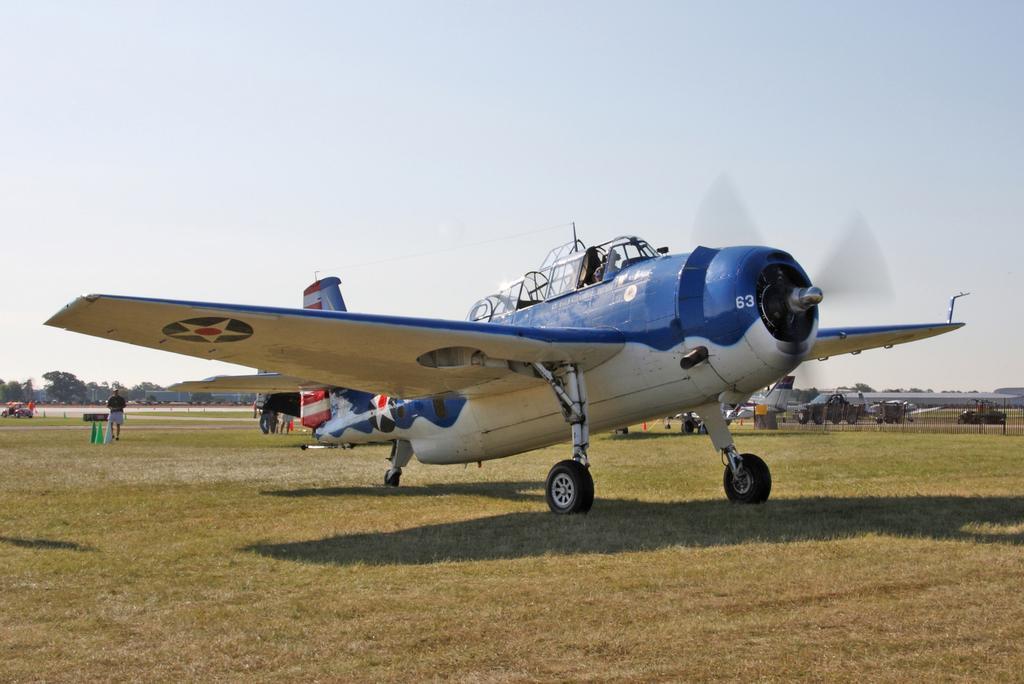How would you summarize this image in a sentence or two? In the center of the image we can see an airplane. In the background of the image we can see some persons, vehicles, mesh, divider cones, trees. At the bottom of the image we can see the ground. At the top of the image we can see the sky. 